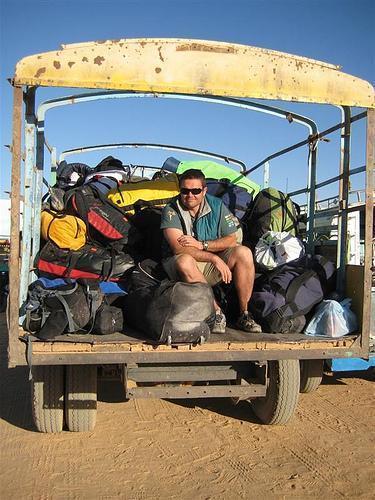How many people are there?
Give a very brief answer. 1. How many suitcases are in the photo?
Give a very brief answer. 3. How many backpacks are in the picture?
Give a very brief answer. 4. 